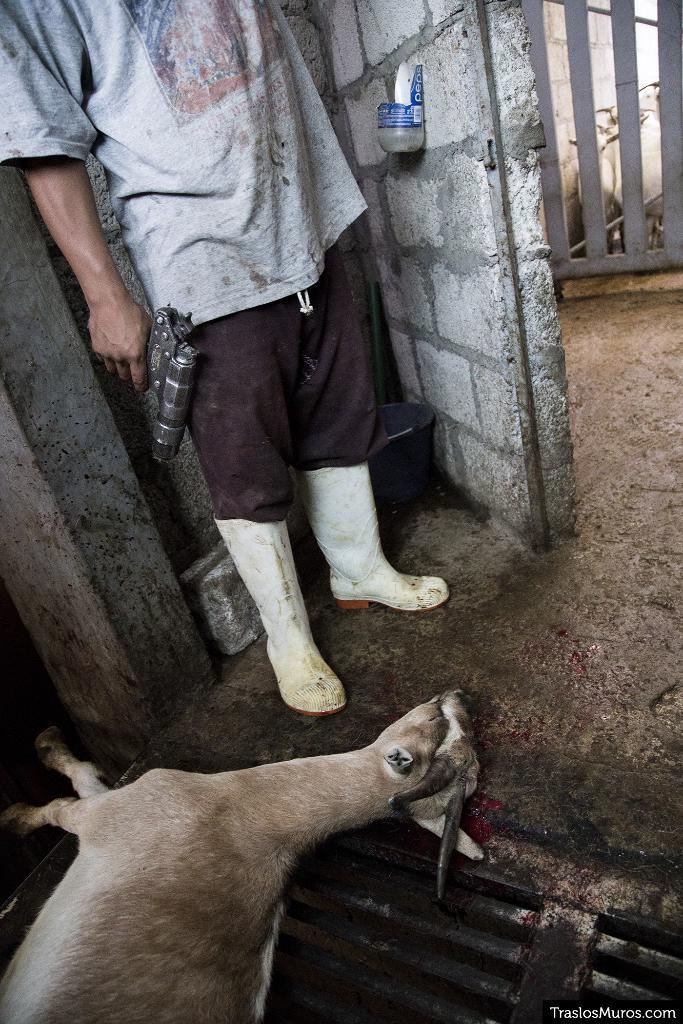What animal can be seen laying on the floor in the image? There is a goat laying on the floor in the image. What is the man in the image doing? The man is standing in the image and holding a gun in his hands. Where is the man positioned in the image? The man is standing beside a wall in the image. What type of location does the image appear to depict? The setting appears to be a slaughter home. What type of space vehicle can be seen in the image? There is no space vehicle present in the image; it depicts a goat and a man in a slaughter home setting. 